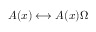<formula> <loc_0><loc_0><loc_500><loc_500>A ( x ) \longleftrightarrow A ( x ) \Omega</formula> 